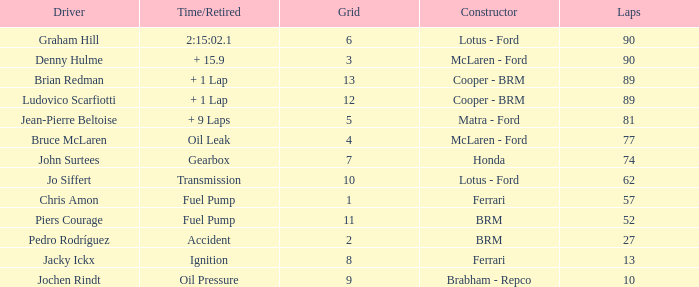What is the time/retired when the laps is 52? Fuel Pump. 